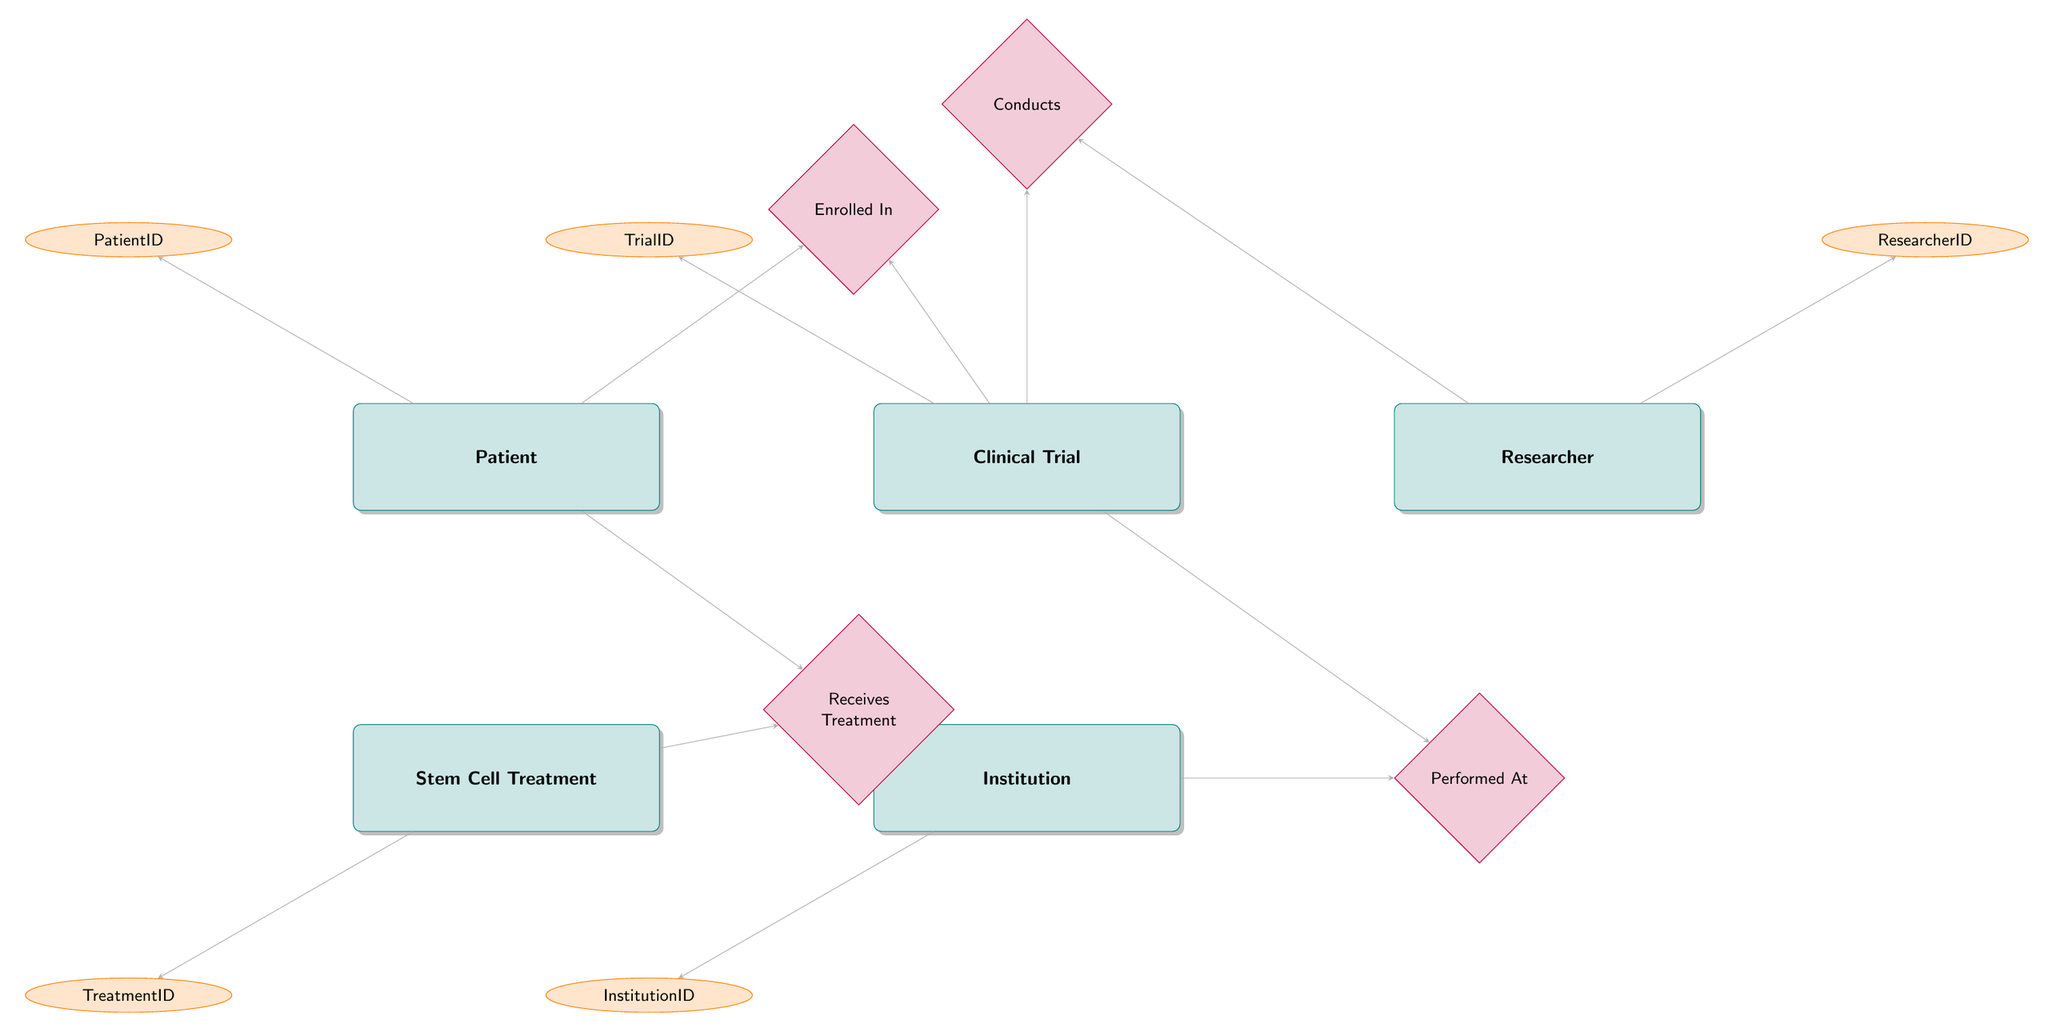What is the name of the relationship between Patient and Clinical Trial? The diagram shows an entity relationship between Patient and Clinical Trial, connected by the relationship labeled "Enrolled In."
Answer: Enrolled In How many entities are in the diagram? Counting the boxes for each entity, we have five entities listed: Patient, Clinical Trial, Stem Cell Treatment, Researcher, and Institution.
Answer: 5 Which entity is connected to the relationship "Receives Treatment"? The "Receives Treatment" relationship connects Patient to Stem Cell Treatment, indicating that patients receive treatments in clinical trials.
Answer: Patient What is the primary key attribute of the Clinical Trial entity? Looking at the attributes listed under Clinical Trial, the primary key is indicated by "TrialID," which uniquely identifies each clinical trial.
Answer: TrialID What type of institution is depicted in the diagram? The Institution entity contains an attribute called "Type," which refers to the classification of the institution where the clinical trials are performed.
Answer: Type How many relationships involve the Clinical Trial entity? In the diagram, Clinical Trial is involved in three relationships: "Enrolled In," "Conducts," and "Performed At," connecting to different entities.
Answer: 3 Which attribute is associated with the Researcher entity? The Researcher entity includes several attributes, but "ResearcherID" is specifically the one used as a unique identifier for researchers leading clinical trials.
Answer: ResearcherID Name a treatment type associated with Stem Cell Treatment. The diagram does not explicitly label specific treatment types but identifies an entity called "Stem Cell Treatment," under which various types can be categorized.
Answer: Type Which two entities are connected by the relationship "Conducts"? The "Conducts" relationship connects Researcher to Clinical Trial, illustrating that researchers oversee or manage the trials.
Answer: Researcher and Clinical Trial 